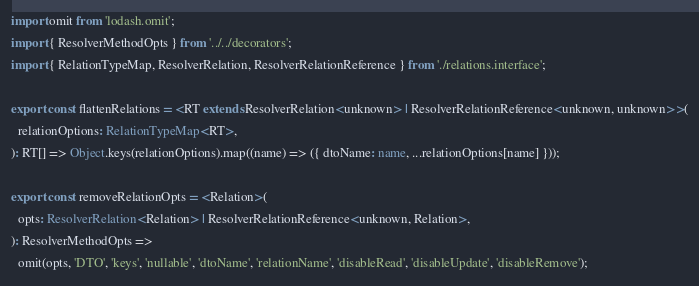Convert code to text. <code><loc_0><loc_0><loc_500><loc_500><_TypeScript_>import omit from 'lodash.omit';
import { ResolverMethodOpts } from '../../decorators';
import { RelationTypeMap, ResolverRelation, ResolverRelationReference } from './relations.interface';

export const flattenRelations = <RT extends ResolverRelation<unknown> | ResolverRelationReference<unknown, unknown>>(
  relationOptions: RelationTypeMap<RT>,
): RT[] => Object.keys(relationOptions).map((name) => ({ dtoName: name, ...relationOptions[name] }));

export const removeRelationOpts = <Relation>(
  opts: ResolverRelation<Relation> | ResolverRelationReference<unknown, Relation>,
): ResolverMethodOpts =>
  omit(opts, 'DTO', 'keys', 'nullable', 'dtoName', 'relationName', 'disableRead', 'disableUpdate', 'disableRemove');
</code> 